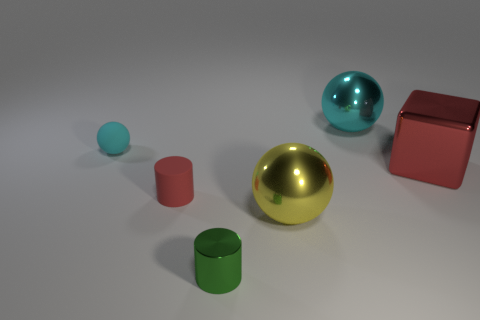Are any tiny yellow rubber spheres visible?
Make the answer very short. No. There is a rubber cylinder that is the same color as the metallic cube; what is its size?
Keep it short and to the point. Small. There is a yellow metal sphere in front of the big ball that is behind the rubber object that is behind the red shiny block; what size is it?
Make the answer very short. Large. How many big yellow balls have the same material as the big cyan ball?
Offer a terse response. 1. What number of red metal blocks are the same size as the green metal cylinder?
Offer a very short reply. 0. What is the cylinder that is in front of the metal ball in front of the cyan thing that is right of the small red matte thing made of?
Ensure brevity in your answer.  Metal. How many things are large green matte things or big cyan shiny things?
Keep it short and to the point. 1. The tiny metal thing is what shape?
Give a very brief answer. Cylinder. There is a cyan thing that is to the right of the cyan sphere left of the large yellow shiny ball; what shape is it?
Offer a terse response. Sphere. Does the sphere that is on the left side of the yellow metallic thing have the same material as the small red object?
Provide a short and direct response. Yes. 